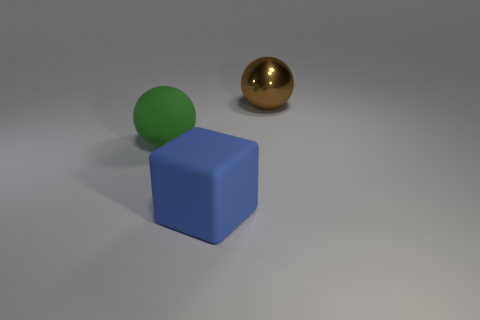Can you describe the lighting and shadows in the scene? The scene is illuminated from a direction that is not visible in the image, casting a shadow to the right of the objects, indicating the light source is to the left. The shadows are soft-edged, suggesting that the light source is diffused, possibly mimicking an overcast sky. The shadows help to give a sense of the dimension and position of the objects in the space. 